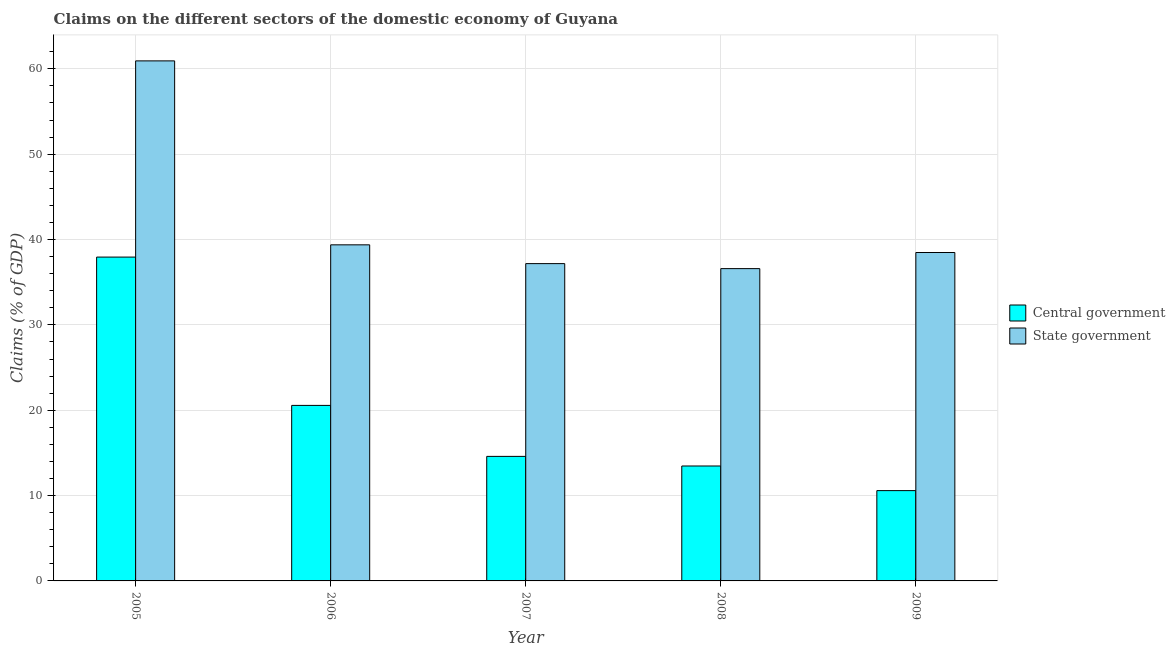Are the number of bars on each tick of the X-axis equal?
Offer a terse response. Yes. In how many cases, is the number of bars for a given year not equal to the number of legend labels?
Make the answer very short. 0. What is the claims on central government in 2006?
Offer a terse response. 20.56. Across all years, what is the maximum claims on central government?
Your response must be concise. 37.94. Across all years, what is the minimum claims on state government?
Offer a terse response. 36.59. In which year was the claims on central government minimum?
Keep it short and to the point. 2009. What is the total claims on central government in the graph?
Your answer should be compact. 97.14. What is the difference between the claims on central government in 2005 and that in 2007?
Offer a very short reply. 23.35. What is the difference between the claims on state government in 2008 and the claims on central government in 2007?
Provide a succinct answer. -0.59. What is the average claims on state government per year?
Ensure brevity in your answer.  42.51. In how many years, is the claims on state government greater than 2 %?
Offer a very short reply. 5. What is the ratio of the claims on state government in 2007 to that in 2009?
Give a very brief answer. 0.97. Is the claims on state government in 2005 less than that in 2006?
Your response must be concise. No. Is the difference between the claims on state government in 2007 and 2009 greater than the difference between the claims on central government in 2007 and 2009?
Provide a succinct answer. No. What is the difference between the highest and the second highest claims on central government?
Make the answer very short. 17.38. What is the difference between the highest and the lowest claims on state government?
Ensure brevity in your answer.  24.34. In how many years, is the claims on state government greater than the average claims on state government taken over all years?
Give a very brief answer. 1. Is the sum of the claims on central government in 2006 and 2007 greater than the maximum claims on state government across all years?
Keep it short and to the point. No. What does the 1st bar from the left in 2005 represents?
Provide a short and direct response. Central government. What does the 2nd bar from the right in 2006 represents?
Keep it short and to the point. Central government. How many bars are there?
Make the answer very short. 10. Are all the bars in the graph horizontal?
Make the answer very short. No. How many years are there in the graph?
Your response must be concise. 5. Are the values on the major ticks of Y-axis written in scientific E-notation?
Make the answer very short. No. Does the graph contain any zero values?
Provide a short and direct response. No. How many legend labels are there?
Ensure brevity in your answer.  2. How are the legend labels stacked?
Your answer should be compact. Vertical. What is the title of the graph?
Provide a short and direct response. Claims on the different sectors of the domestic economy of Guyana. Does "Merchandise exports" appear as one of the legend labels in the graph?
Provide a short and direct response. No. What is the label or title of the X-axis?
Your response must be concise. Year. What is the label or title of the Y-axis?
Ensure brevity in your answer.  Claims (% of GDP). What is the Claims (% of GDP) in Central government in 2005?
Provide a succinct answer. 37.94. What is the Claims (% of GDP) of State government in 2005?
Your answer should be compact. 60.93. What is the Claims (% of GDP) of Central government in 2006?
Provide a succinct answer. 20.56. What is the Claims (% of GDP) in State government in 2006?
Make the answer very short. 39.38. What is the Claims (% of GDP) of Central government in 2007?
Provide a short and direct response. 14.59. What is the Claims (% of GDP) in State government in 2007?
Provide a short and direct response. 37.18. What is the Claims (% of GDP) of Central government in 2008?
Offer a very short reply. 13.47. What is the Claims (% of GDP) of State government in 2008?
Keep it short and to the point. 36.59. What is the Claims (% of GDP) in Central government in 2009?
Your answer should be compact. 10.58. What is the Claims (% of GDP) of State government in 2009?
Provide a short and direct response. 38.48. Across all years, what is the maximum Claims (% of GDP) of Central government?
Make the answer very short. 37.94. Across all years, what is the maximum Claims (% of GDP) in State government?
Your answer should be compact. 60.93. Across all years, what is the minimum Claims (% of GDP) of Central government?
Your response must be concise. 10.58. Across all years, what is the minimum Claims (% of GDP) in State government?
Give a very brief answer. 36.59. What is the total Claims (% of GDP) in Central government in the graph?
Give a very brief answer. 97.14. What is the total Claims (% of GDP) of State government in the graph?
Your answer should be compact. 212.55. What is the difference between the Claims (% of GDP) of Central government in 2005 and that in 2006?
Ensure brevity in your answer.  17.38. What is the difference between the Claims (% of GDP) in State government in 2005 and that in 2006?
Your answer should be compact. 21.55. What is the difference between the Claims (% of GDP) in Central government in 2005 and that in 2007?
Ensure brevity in your answer.  23.35. What is the difference between the Claims (% of GDP) in State government in 2005 and that in 2007?
Offer a terse response. 23.75. What is the difference between the Claims (% of GDP) of Central government in 2005 and that in 2008?
Give a very brief answer. 24.48. What is the difference between the Claims (% of GDP) in State government in 2005 and that in 2008?
Ensure brevity in your answer.  24.34. What is the difference between the Claims (% of GDP) in Central government in 2005 and that in 2009?
Keep it short and to the point. 27.36. What is the difference between the Claims (% of GDP) in State government in 2005 and that in 2009?
Make the answer very short. 22.45. What is the difference between the Claims (% of GDP) of Central government in 2006 and that in 2007?
Make the answer very short. 5.97. What is the difference between the Claims (% of GDP) in State government in 2006 and that in 2007?
Your response must be concise. 2.2. What is the difference between the Claims (% of GDP) of Central government in 2006 and that in 2008?
Your answer should be very brief. 7.1. What is the difference between the Claims (% of GDP) in State government in 2006 and that in 2008?
Your answer should be very brief. 2.79. What is the difference between the Claims (% of GDP) in Central government in 2006 and that in 2009?
Offer a very short reply. 9.98. What is the difference between the Claims (% of GDP) in State government in 2006 and that in 2009?
Your answer should be compact. 0.9. What is the difference between the Claims (% of GDP) in Central government in 2007 and that in 2008?
Give a very brief answer. 1.13. What is the difference between the Claims (% of GDP) in State government in 2007 and that in 2008?
Offer a terse response. 0.59. What is the difference between the Claims (% of GDP) of Central government in 2007 and that in 2009?
Give a very brief answer. 4.01. What is the difference between the Claims (% of GDP) in State government in 2007 and that in 2009?
Ensure brevity in your answer.  -1.3. What is the difference between the Claims (% of GDP) of Central government in 2008 and that in 2009?
Offer a very short reply. 2.89. What is the difference between the Claims (% of GDP) in State government in 2008 and that in 2009?
Your response must be concise. -1.89. What is the difference between the Claims (% of GDP) in Central government in 2005 and the Claims (% of GDP) in State government in 2006?
Make the answer very short. -1.44. What is the difference between the Claims (% of GDP) in Central government in 2005 and the Claims (% of GDP) in State government in 2007?
Your answer should be compact. 0.77. What is the difference between the Claims (% of GDP) of Central government in 2005 and the Claims (% of GDP) of State government in 2008?
Ensure brevity in your answer.  1.35. What is the difference between the Claims (% of GDP) in Central government in 2005 and the Claims (% of GDP) in State government in 2009?
Give a very brief answer. -0.54. What is the difference between the Claims (% of GDP) in Central government in 2006 and the Claims (% of GDP) in State government in 2007?
Offer a very short reply. -16.61. What is the difference between the Claims (% of GDP) in Central government in 2006 and the Claims (% of GDP) in State government in 2008?
Make the answer very short. -16.03. What is the difference between the Claims (% of GDP) of Central government in 2006 and the Claims (% of GDP) of State government in 2009?
Give a very brief answer. -17.91. What is the difference between the Claims (% of GDP) in Central government in 2007 and the Claims (% of GDP) in State government in 2008?
Ensure brevity in your answer.  -22. What is the difference between the Claims (% of GDP) of Central government in 2007 and the Claims (% of GDP) of State government in 2009?
Keep it short and to the point. -23.89. What is the difference between the Claims (% of GDP) of Central government in 2008 and the Claims (% of GDP) of State government in 2009?
Offer a very short reply. -25.01. What is the average Claims (% of GDP) in Central government per year?
Offer a very short reply. 19.43. What is the average Claims (% of GDP) of State government per year?
Offer a terse response. 42.51. In the year 2005, what is the difference between the Claims (% of GDP) in Central government and Claims (% of GDP) in State government?
Your response must be concise. -22.99. In the year 2006, what is the difference between the Claims (% of GDP) in Central government and Claims (% of GDP) in State government?
Offer a very short reply. -18.81. In the year 2007, what is the difference between the Claims (% of GDP) of Central government and Claims (% of GDP) of State government?
Provide a short and direct response. -22.58. In the year 2008, what is the difference between the Claims (% of GDP) of Central government and Claims (% of GDP) of State government?
Provide a short and direct response. -23.12. In the year 2009, what is the difference between the Claims (% of GDP) in Central government and Claims (% of GDP) in State government?
Offer a very short reply. -27.9. What is the ratio of the Claims (% of GDP) in Central government in 2005 to that in 2006?
Make the answer very short. 1.84. What is the ratio of the Claims (% of GDP) in State government in 2005 to that in 2006?
Provide a succinct answer. 1.55. What is the ratio of the Claims (% of GDP) in Central government in 2005 to that in 2007?
Provide a succinct answer. 2.6. What is the ratio of the Claims (% of GDP) in State government in 2005 to that in 2007?
Your response must be concise. 1.64. What is the ratio of the Claims (% of GDP) of Central government in 2005 to that in 2008?
Give a very brief answer. 2.82. What is the ratio of the Claims (% of GDP) of State government in 2005 to that in 2008?
Offer a very short reply. 1.67. What is the ratio of the Claims (% of GDP) in Central government in 2005 to that in 2009?
Make the answer very short. 3.59. What is the ratio of the Claims (% of GDP) in State government in 2005 to that in 2009?
Your answer should be very brief. 1.58. What is the ratio of the Claims (% of GDP) of Central government in 2006 to that in 2007?
Offer a terse response. 1.41. What is the ratio of the Claims (% of GDP) of State government in 2006 to that in 2007?
Give a very brief answer. 1.06. What is the ratio of the Claims (% of GDP) in Central government in 2006 to that in 2008?
Provide a short and direct response. 1.53. What is the ratio of the Claims (% of GDP) of State government in 2006 to that in 2008?
Ensure brevity in your answer.  1.08. What is the ratio of the Claims (% of GDP) of Central government in 2006 to that in 2009?
Offer a very short reply. 1.94. What is the ratio of the Claims (% of GDP) in State government in 2006 to that in 2009?
Provide a succinct answer. 1.02. What is the ratio of the Claims (% of GDP) of Central government in 2007 to that in 2008?
Provide a short and direct response. 1.08. What is the ratio of the Claims (% of GDP) of State government in 2007 to that in 2008?
Offer a very short reply. 1.02. What is the ratio of the Claims (% of GDP) of Central government in 2007 to that in 2009?
Keep it short and to the point. 1.38. What is the ratio of the Claims (% of GDP) of State government in 2007 to that in 2009?
Keep it short and to the point. 0.97. What is the ratio of the Claims (% of GDP) of Central government in 2008 to that in 2009?
Your answer should be very brief. 1.27. What is the ratio of the Claims (% of GDP) of State government in 2008 to that in 2009?
Your answer should be compact. 0.95. What is the difference between the highest and the second highest Claims (% of GDP) of Central government?
Offer a very short reply. 17.38. What is the difference between the highest and the second highest Claims (% of GDP) of State government?
Keep it short and to the point. 21.55. What is the difference between the highest and the lowest Claims (% of GDP) in Central government?
Offer a very short reply. 27.36. What is the difference between the highest and the lowest Claims (% of GDP) of State government?
Your answer should be very brief. 24.34. 